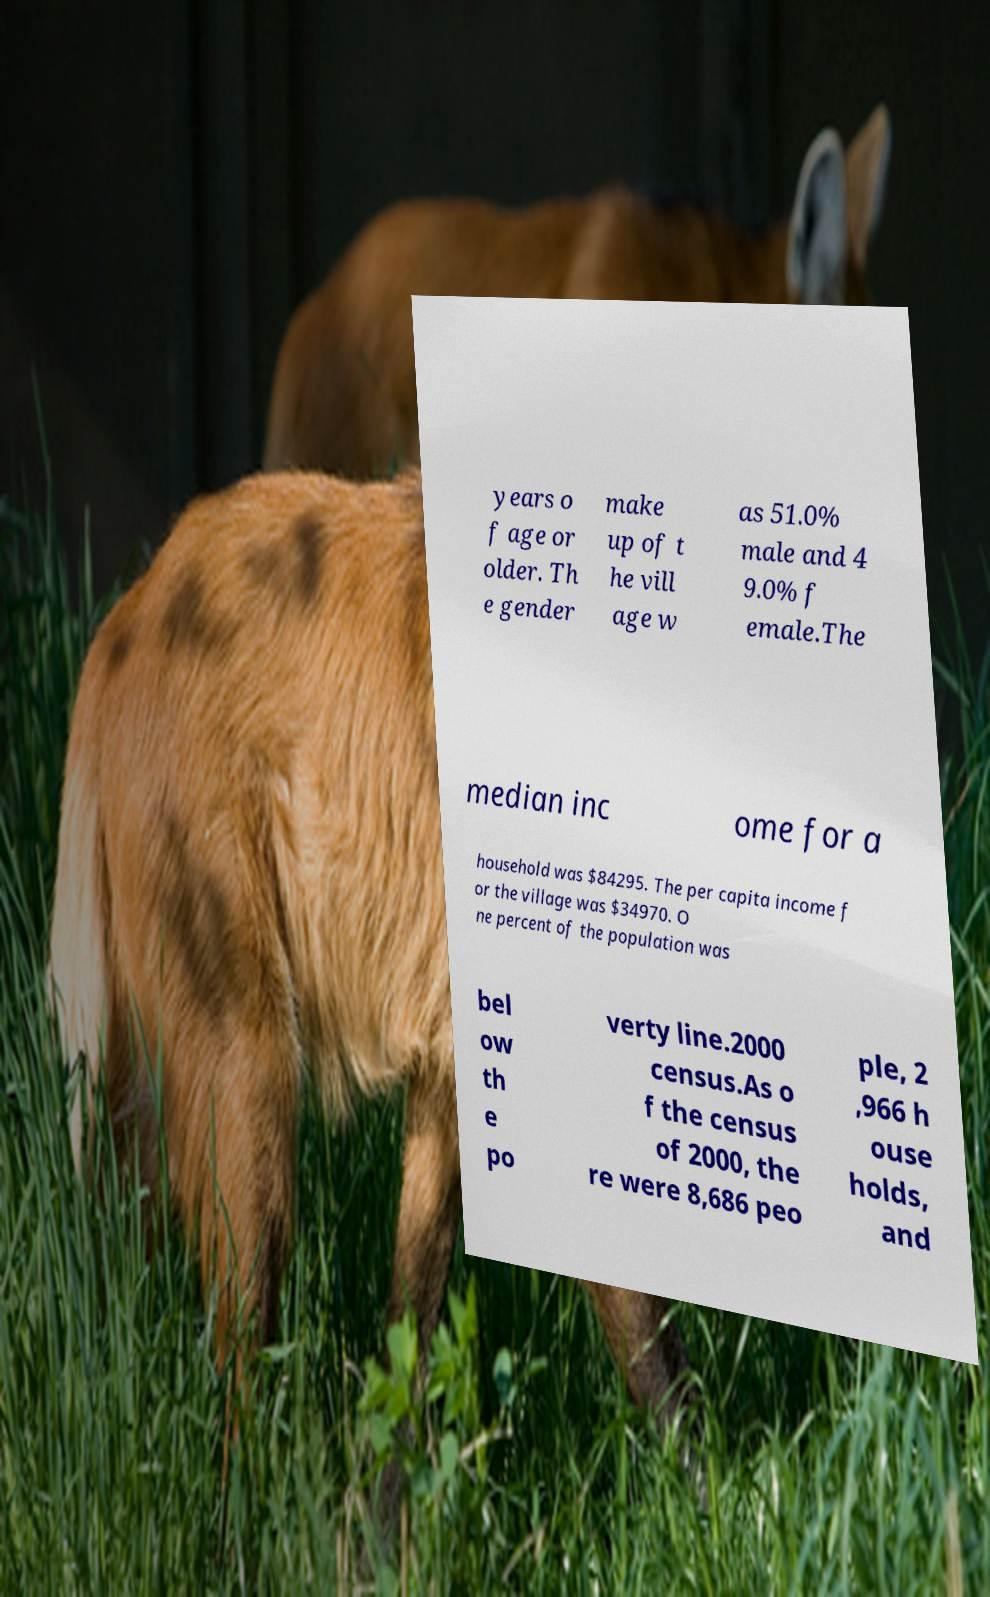Please read and relay the text visible in this image. What does it say? years o f age or older. Th e gender make up of t he vill age w as 51.0% male and 4 9.0% f emale.The median inc ome for a household was $84295. The per capita income f or the village was $34970. O ne percent of the population was bel ow th e po verty line.2000 census.As o f the census of 2000, the re were 8,686 peo ple, 2 ,966 h ouse holds, and 